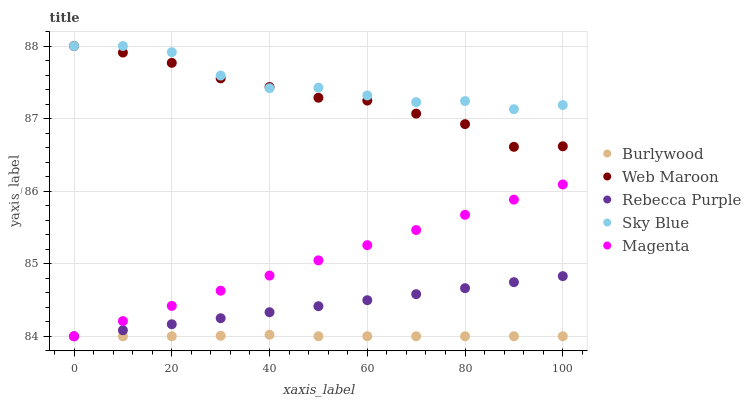Does Burlywood have the minimum area under the curve?
Answer yes or no. Yes. Does Sky Blue have the maximum area under the curve?
Answer yes or no. Yes. Does Magenta have the minimum area under the curve?
Answer yes or no. No. Does Magenta have the maximum area under the curve?
Answer yes or no. No. Is Magenta the smoothest?
Answer yes or no. Yes. Is Sky Blue the roughest?
Answer yes or no. Yes. Is Sky Blue the smoothest?
Answer yes or no. No. Is Magenta the roughest?
Answer yes or no. No. Does Burlywood have the lowest value?
Answer yes or no. Yes. Does Sky Blue have the lowest value?
Answer yes or no. No. Does Web Maroon have the highest value?
Answer yes or no. Yes. Does Magenta have the highest value?
Answer yes or no. No. Is Magenta less than Web Maroon?
Answer yes or no. Yes. Is Web Maroon greater than Rebecca Purple?
Answer yes or no. Yes. Does Magenta intersect Burlywood?
Answer yes or no. Yes. Is Magenta less than Burlywood?
Answer yes or no. No. Is Magenta greater than Burlywood?
Answer yes or no. No. Does Magenta intersect Web Maroon?
Answer yes or no. No. 